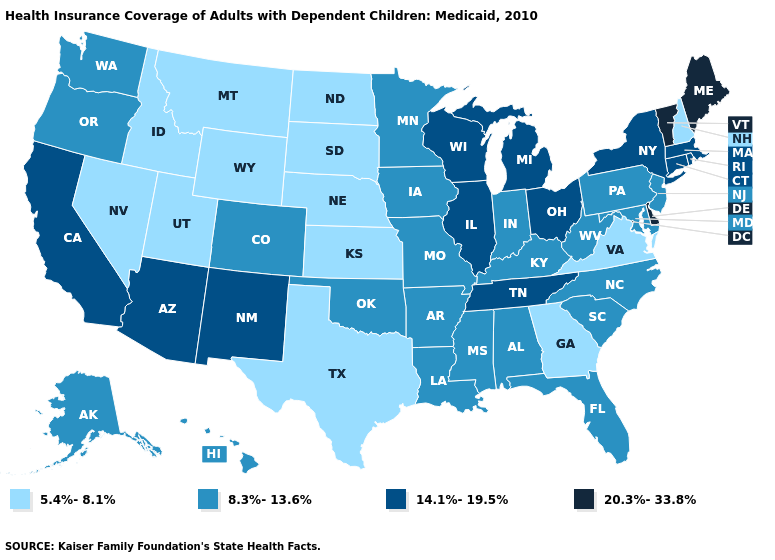Name the states that have a value in the range 20.3%-33.8%?
Answer briefly. Delaware, Maine, Vermont. What is the lowest value in the MidWest?
Give a very brief answer. 5.4%-8.1%. How many symbols are there in the legend?
Write a very short answer. 4. Name the states that have a value in the range 20.3%-33.8%?
Quick response, please. Delaware, Maine, Vermont. What is the lowest value in states that border Delaware?
Concise answer only. 8.3%-13.6%. Does Vermont have a higher value than Michigan?
Keep it brief. Yes. Does the map have missing data?
Write a very short answer. No. Which states have the lowest value in the USA?
Short answer required. Georgia, Idaho, Kansas, Montana, Nebraska, Nevada, New Hampshire, North Dakota, South Dakota, Texas, Utah, Virginia, Wyoming. Does Virginia have the lowest value in the USA?
Be succinct. Yes. What is the highest value in the USA?
Keep it brief. 20.3%-33.8%. What is the value of Oregon?
Quick response, please. 8.3%-13.6%. What is the value of Missouri?
Short answer required. 8.3%-13.6%. What is the highest value in the South ?
Quick response, please. 20.3%-33.8%. Name the states that have a value in the range 8.3%-13.6%?
Be succinct. Alabama, Alaska, Arkansas, Colorado, Florida, Hawaii, Indiana, Iowa, Kentucky, Louisiana, Maryland, Minnesota, Mississippi, Missouri, New Jersey, North Carolina, Oklahoma, Oregon, Pennsylvania, South Carolina, Washington, West Virginia. What is the lowest value in the South?
Short answer required. 5.4%-8.1%. 